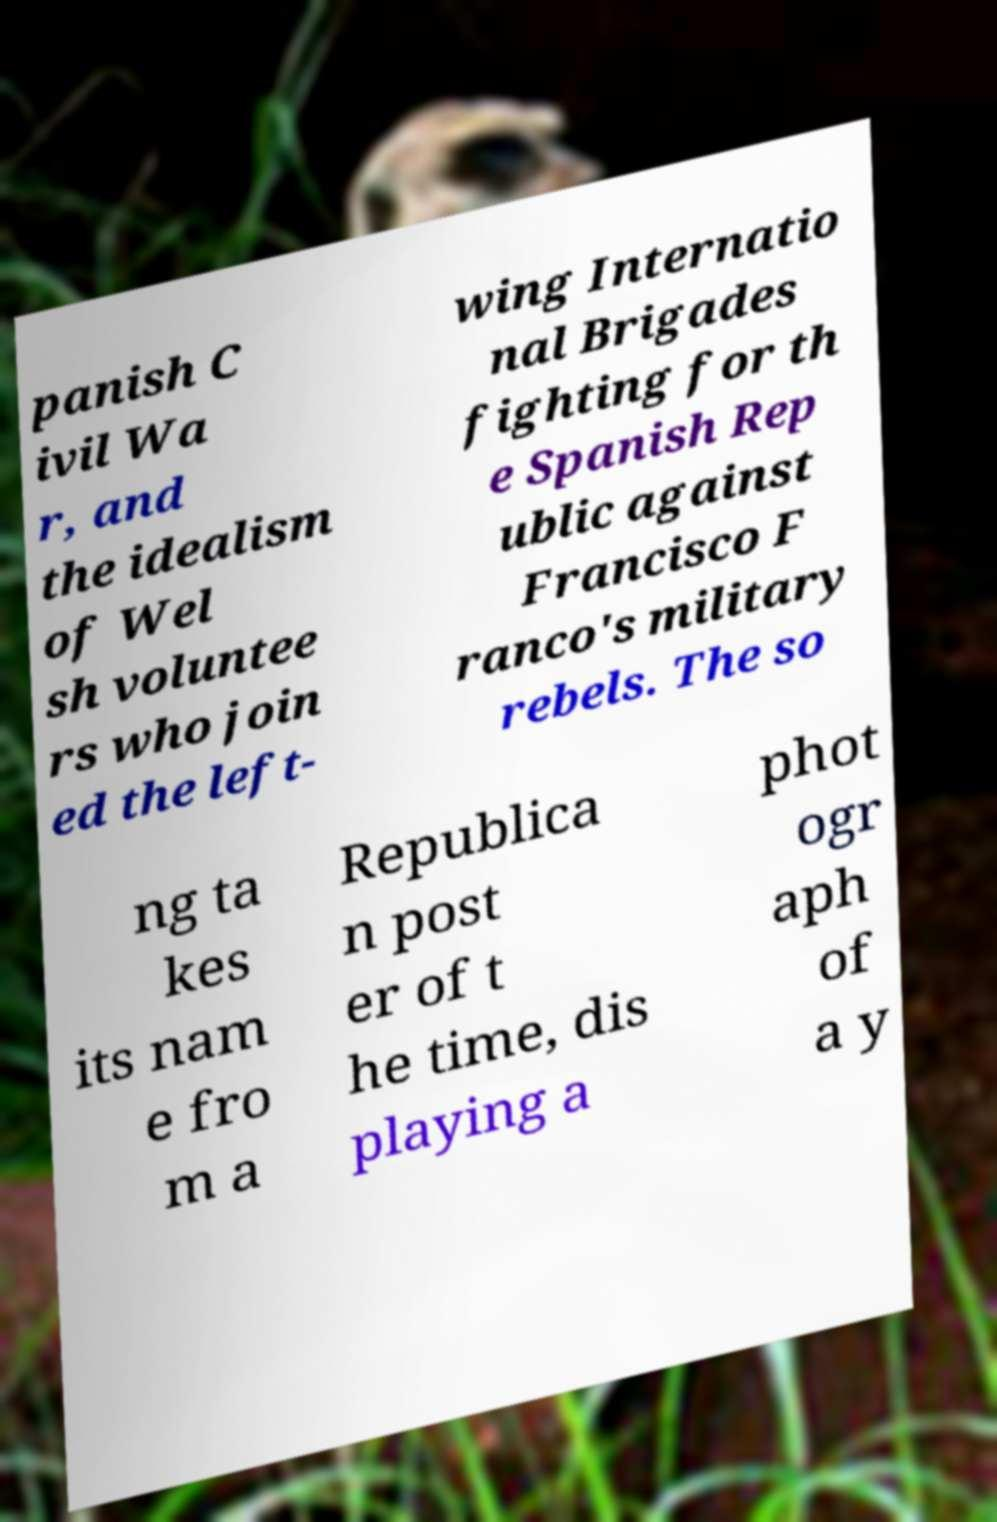I need the written content from this picture converted into text. Can you do that? panish C ivil Wa r, and the idealism of Wel sh voluntee rs who join ed the left- wing Internatio nal Brigades fighting for th e Spanish Rep ublic against Francisco F ranco's military rebels. The so ng ta kes its nam e fro m a Republica n post er of t he time, dis playing a phot ogr aph of a y 